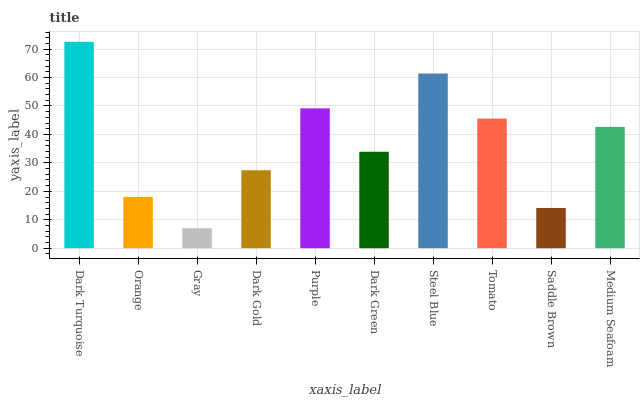Is Orange the minimum?
Answer yes or no. No. Is Orange the maximum?
Answer yes or no. No. Is Dark Turquoise greater than Orange?
Answer yes or no. Yes. Is Orange less than Dark Turquoise?
Answer yes or no. Yes. Is Orange greater than Dark Turquoise?
Answer yes or no. No. Is Dark Turquoise less than Orange?
Answer yes or no. No. Is Medium Seafoam the high median?
Answer yes or no. Yes. Is Dark Green the low median?
Answer yes or no. Yes. Is Steel Blue the high median?
Answer yes or no. No. Is Saddle Brown the low median?
Answer yes or no. No. 